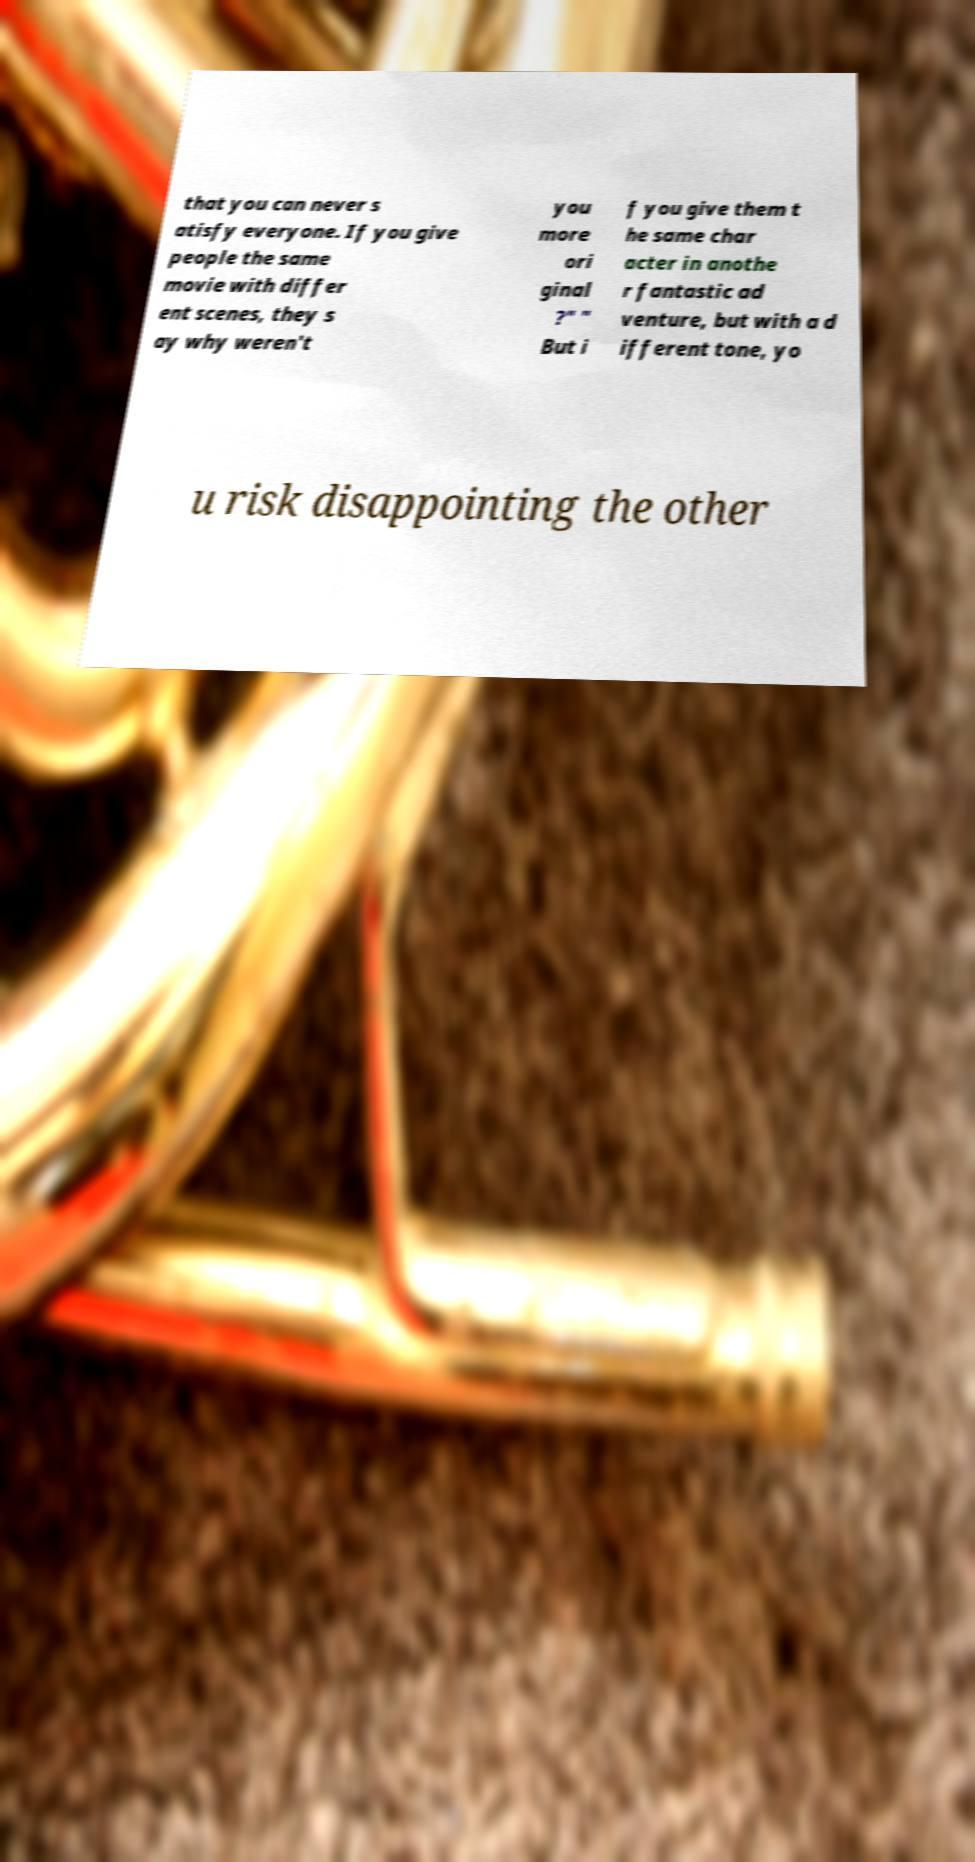Could you extract and type out the text from this image? that you can never s atisfy everyone. If you give people the same movie with differ ent scenes, they s ay why weren't you more ori ginal ?" " But i f you give them t he same char acter in anothe r fantastic ad venture, but with a d ifferent tone, yo u risk disappointing the other 